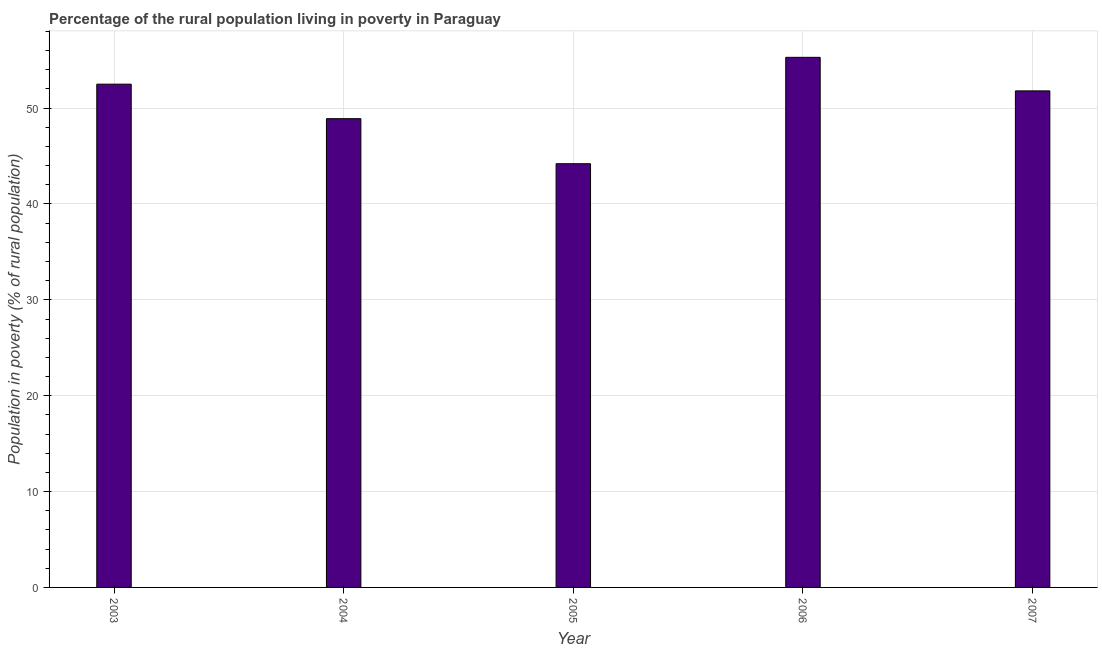Does the graph contain any zero values?
Your answer should be compact. No. Does the graph contain grids?
Keep it short and to the point. Yes. What is the title of the graph?
Provide a short and direct response. Percentage of the rural population living in poverty in Paraguay. What is the label or title of the X-axis?
Provide a succinct answer. Year. What is the label or title of the Y-axis?
Ensure brevity in your answer.  Population in poverty (% of rural population). What is the percentage of rural population living below poverty line in 2003?
Provide a succinct answer. 52.5. Across all years, what is the maximum percentage of rural population living below poverty line?
Make the answer very short. 55.3. Across all years, what is the minimum percentage of rural population living below poverty line?
Keep it short and to the point. 44.2. In which year was the percentage of rural population living below poverty line maximum?
Offer a very short reply. 2006. What is the sum of the percentage of rural population living below poverty line?
Offer a very short reply. 252.7. What is the difference between the percentage of rural population living below poverty line in 2003 and 2006?
Provide a short and direct response. -2.8. What is the average percentage of rural population living below poverty line per year?
Offer a terse response. 50.54. What is the median percentage of rural population living below poverty line?
Keep it short and to the point. 51.8. In how many years, is the percentage of rural population living below poverty line greater than 4 %?
Offer a terse response. 5. What is the ratio of the percentage of rural population living below poverty line in 2005 to that in 2007?
Your answer should be compact. 0.85. Is the difference between the percentage of rural population living below poverty line in 2005 and 2007 greater than the difference between any two years?
Make the answer very short. No. What is the difference between the highest and the second highest percentage of rural population living below poverty line?
Your answer should be compact. 2.8. Is the sum of the percentage of rural population living below poverty line in 2003 and 2006 greater than the maximum percentage of rural population living below poverty line across all years?
Provide a succinct answer. Yes. What is the difference between the highest and the lowest percentage of rural population living below poverty line?
Make the answer very short. 11.1. How many bars are there?
Keep it short and to the point. 5. Are the values on the major ticks of Y-axis written in scientific E-notation?
Your answer should be compact. No. What is the Population in poverty (% of rural population) in 2003?
Offer a terse response. 52.5. What is the Population in poverty (% of rural population) in 2004?
Ensure brevity in your answer.  48.9. What is the Population in poverty (% of rural population) in 2005?
Keep it short and to the point. 44.2. What is the Population in poverty (% of rural population) of 2006?
Offer a terse response. 55.3. What is the Population in poverty (% of rural population) in 2007?
Provide a succinct answer. 51.8. What is the difference between the Population in poverty (% of rural population) in 2003 and 2005?
Offer a terse response. 8.3. What is the difference between the Population in poverty (% of rural population) in 2003 and 2006?
Offer a terse response. -2.8. What is the difference between the Population in poverty (% of rural population) in 2003 and 2007?
Your answer should be very brief. 0.7. What is the difference between the Population in poverty (% of rural population) in 2004 and 2006?
Provide a succinct answer. -6.4. What is the difference between the Population in poverty (% of rural population) in 2005 and 2006?
Your response must be concise. -11.1. What is the difference between the Population in poverty (% of rural population) in 2005 and 2007?
Your answer should be very brief. -7.6. What is the ratio of the Population in poverty (% of rural population) in 2003 to that in 2004?
Your response must be concise. 1.07. What is the ratio of the Population in poverty (% of rural population) in 2003 to that in 2005?
Your answer should be very brief. 1.19. What is the ratio of the Population in poverty (% of rural population) in 2003 to that in 2006?
Offer a very short reply. 0.95. What is the ratio of the Population in poverty (% of rural population) in 2004 to that in 2005?
Offer a terse response. 1.11. What is the ratio of the Population in poverty (% of rural population) in 2004 to that in 2006?
Your response must be concise. 0.88. What is the ratio of the Population in poverty (% of rural population) in 2004 to that in 2007?
Offer a very short reply. 0.94. What is the ratio of the Population in poverty (% of rural population) in 2005 to that in 2006?
Your answer should be very brief. 0.8. What is the ratio of the Population in poverty (% of rural population) in 2005 to that in 2007?
Give a very brief answer. 0.85. What is the ratio of the Population in poverty (% of rural population) in 2006 to that in 2007?
Your answer should be compact. 1.07. 